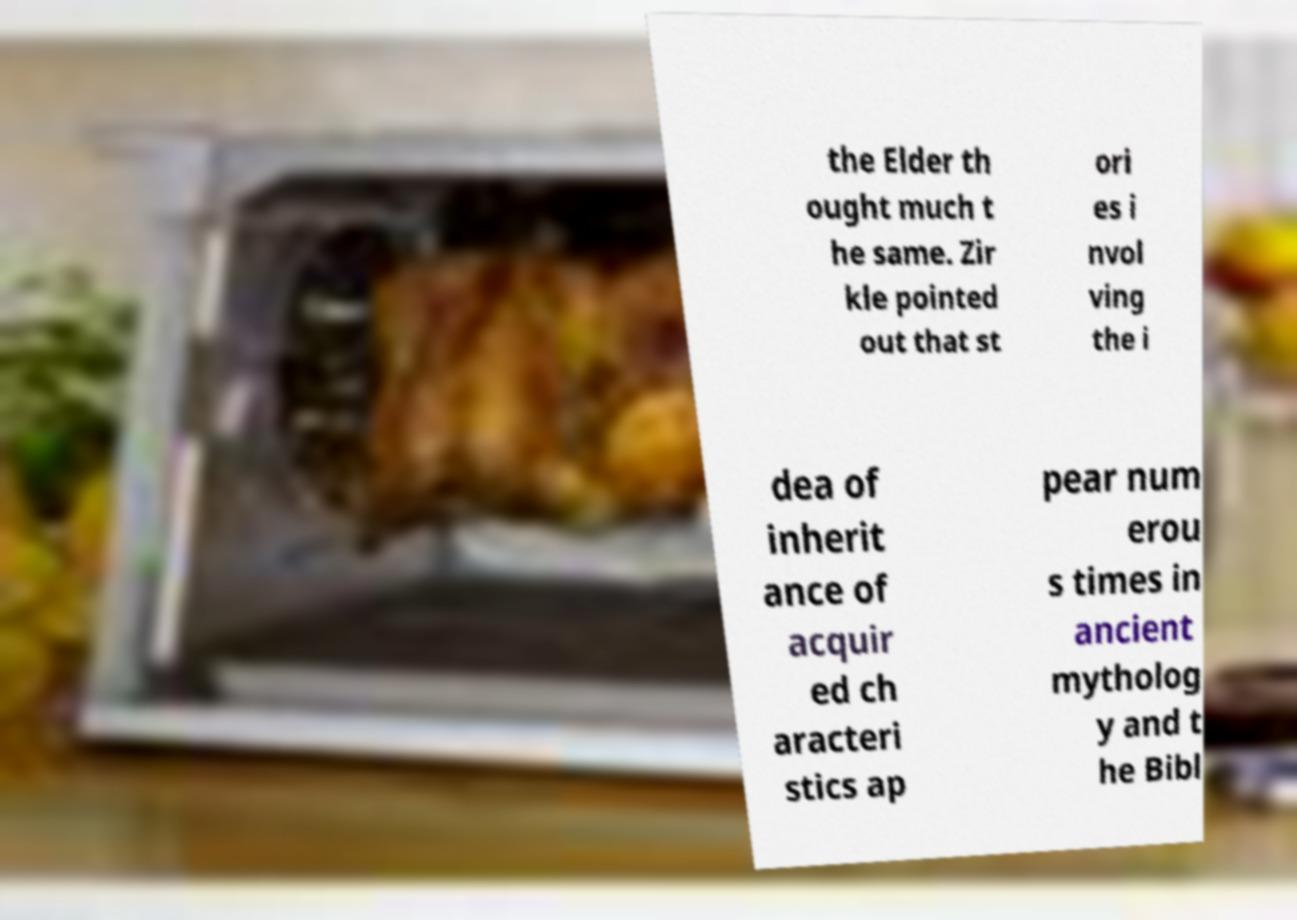Please identify and transcribe the text found in this image. the Elder th ought much t he same. Zir kle pointed out that st ori es i nvol ving the i dea of inherit ance of acquir ed ch aracteri stics ap pear num erou s times in ancient mytholog y and t he Bibl 